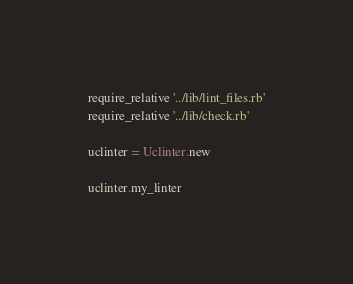<code> <loc_0><loc_0><loc_500><loc_500><_Ruby_>require_relative '../lib/lint_files.rb'
require_relative '../lib/check.rb'

uclinter = Uclinter.new

uclinter.my_linter
</code> 